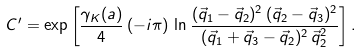Convert formula to latex. <formula><loc_0><loc_0><loc_500><loc_500>C ^ { \prime } = \exp \left [ \frac { \gamma _ { K } ( a ) } { 4 } \, ( - i \pi ) \, \ln \frac { ( \vec { q } _ { 1 } - \vec { q } _ { 2 } ) ^ { 2 } \, ( \vec { q } _ { 2 } - \vec { q } _ { 3 } ) ^ { 2 } } { ( \vec { q } _ { 1 } + \vec { q } _ { 3 } - \vec { q } _ { 2 } ) ^ { 2 } \, \vec { q } _ { 2 } ^ { 2 } } \right ] .</formula> 